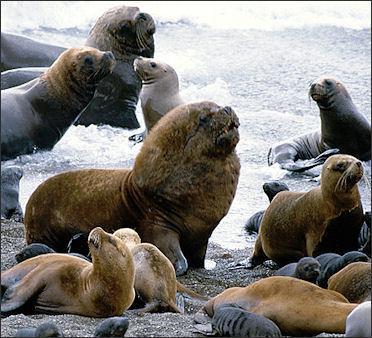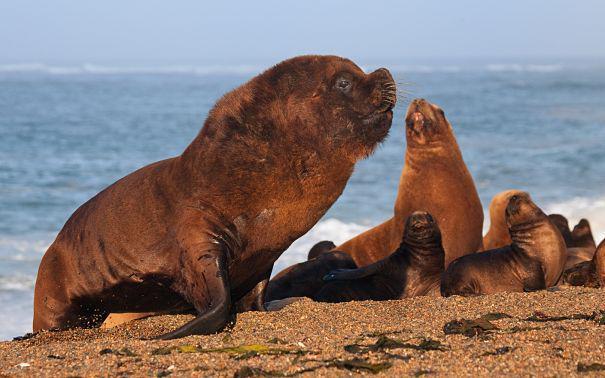The first image is the image on the left, the second image is the image on the right. Analyze the images presented: Is the assertion "There are exactly two animals in the image on the right." valid? Answer yes or no. No. 